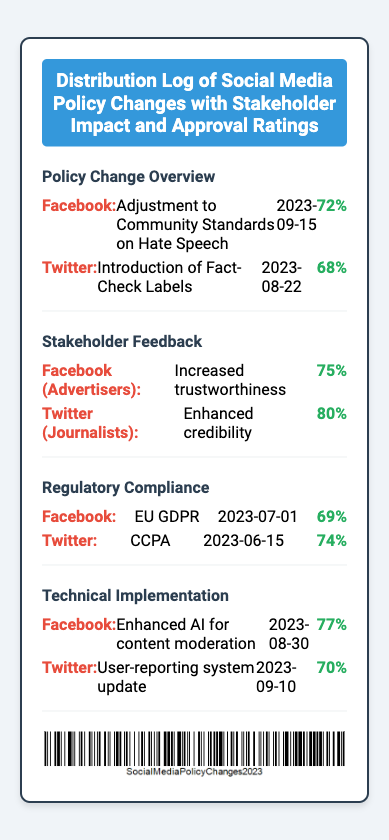What is the date of the policy change on Facebook? The policy change on Facebook regarding Hate Speech was made on September 15, 2023.
Answer: 2023-09-15 What is the approval rating for Twitter's fact-check labels? The approval rating for Twitter's introduction of Fact-Check Labels is 68%.
Answer: 68% What feedback did Facebook advertisers provide? The feedback from Facebook advertisers was that it led to increased trustworthiness.
Answer: Increased trustworthiness Which regulatory compliance was reported by Twitter? Twitter reported compliance with the CCPA on June 15, 2023.
Answer: CCPA What is the approval rating for the technical implementation on Facebook? The approval rating for the enhanced AI for content moderation on Facebook is 77%.
Answer: 77% Which platform had a higher stakeholder approval rating among journalists? Twitter had a higher stakeholder approval rating among journalists at 80%.
Answer: Twitter What is the title of this document? The title of the document is Distribution Log of Social Media Policy Changes with Stakeholder Impact and Approval Ratings.
Answer: Distribution Log of Social Media Policy Changes with Stakeholder Impact and Approval Ratings What was the date of the most recent technical implementation on Twitter? The most recent technical implementation on Twitter was updated on September 10, 2023.
Answer: 2023-09-10 What type of changes does the document log? The document logs social media policy changes.
Answer: Social media policy changes 